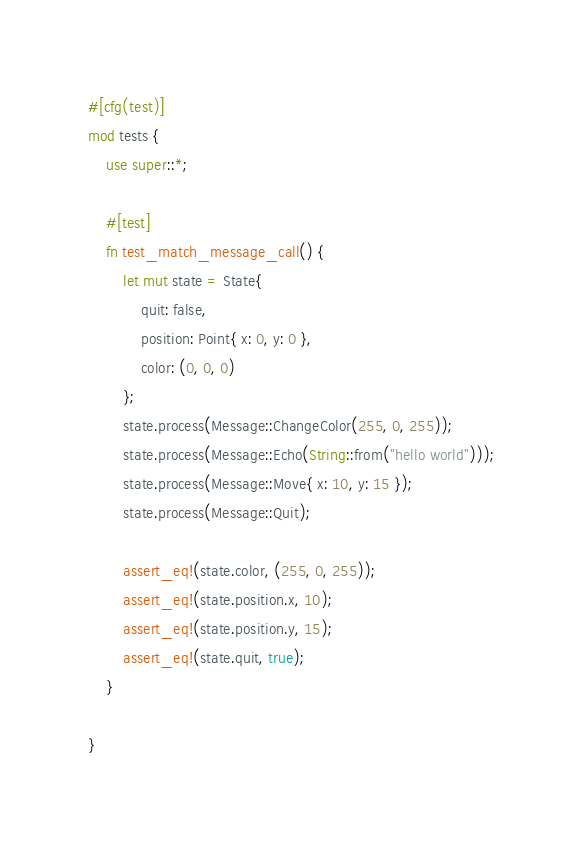Convert code to text. <code><loc_0><loc_0><loc_500><loc_500><_Rust_>#[cfg(test)]
mod tests {
    use super::*;

    #[test]
    fn test_match_message_call() {
        let mut state = State{
            quit: false,
            position: Point{ x: 0, y: 0 },
            color: (0, 0, 0)
        };
        state.process(Message::ChangeColor(255, 0, 255));
        state.process(Message::Echo(String::from("hello world")));
        state.process(Message::Move{ x: 10, y: 15 });
        state.process(Message::Quit);

        assert_eq!(state.color, (255, 0, 255));
        assert_eq!(state.position.x, 10);
        assert_eq!(state.position.y, 15);
        assert_eq!(state.quit, true);
    }

}
</code> 